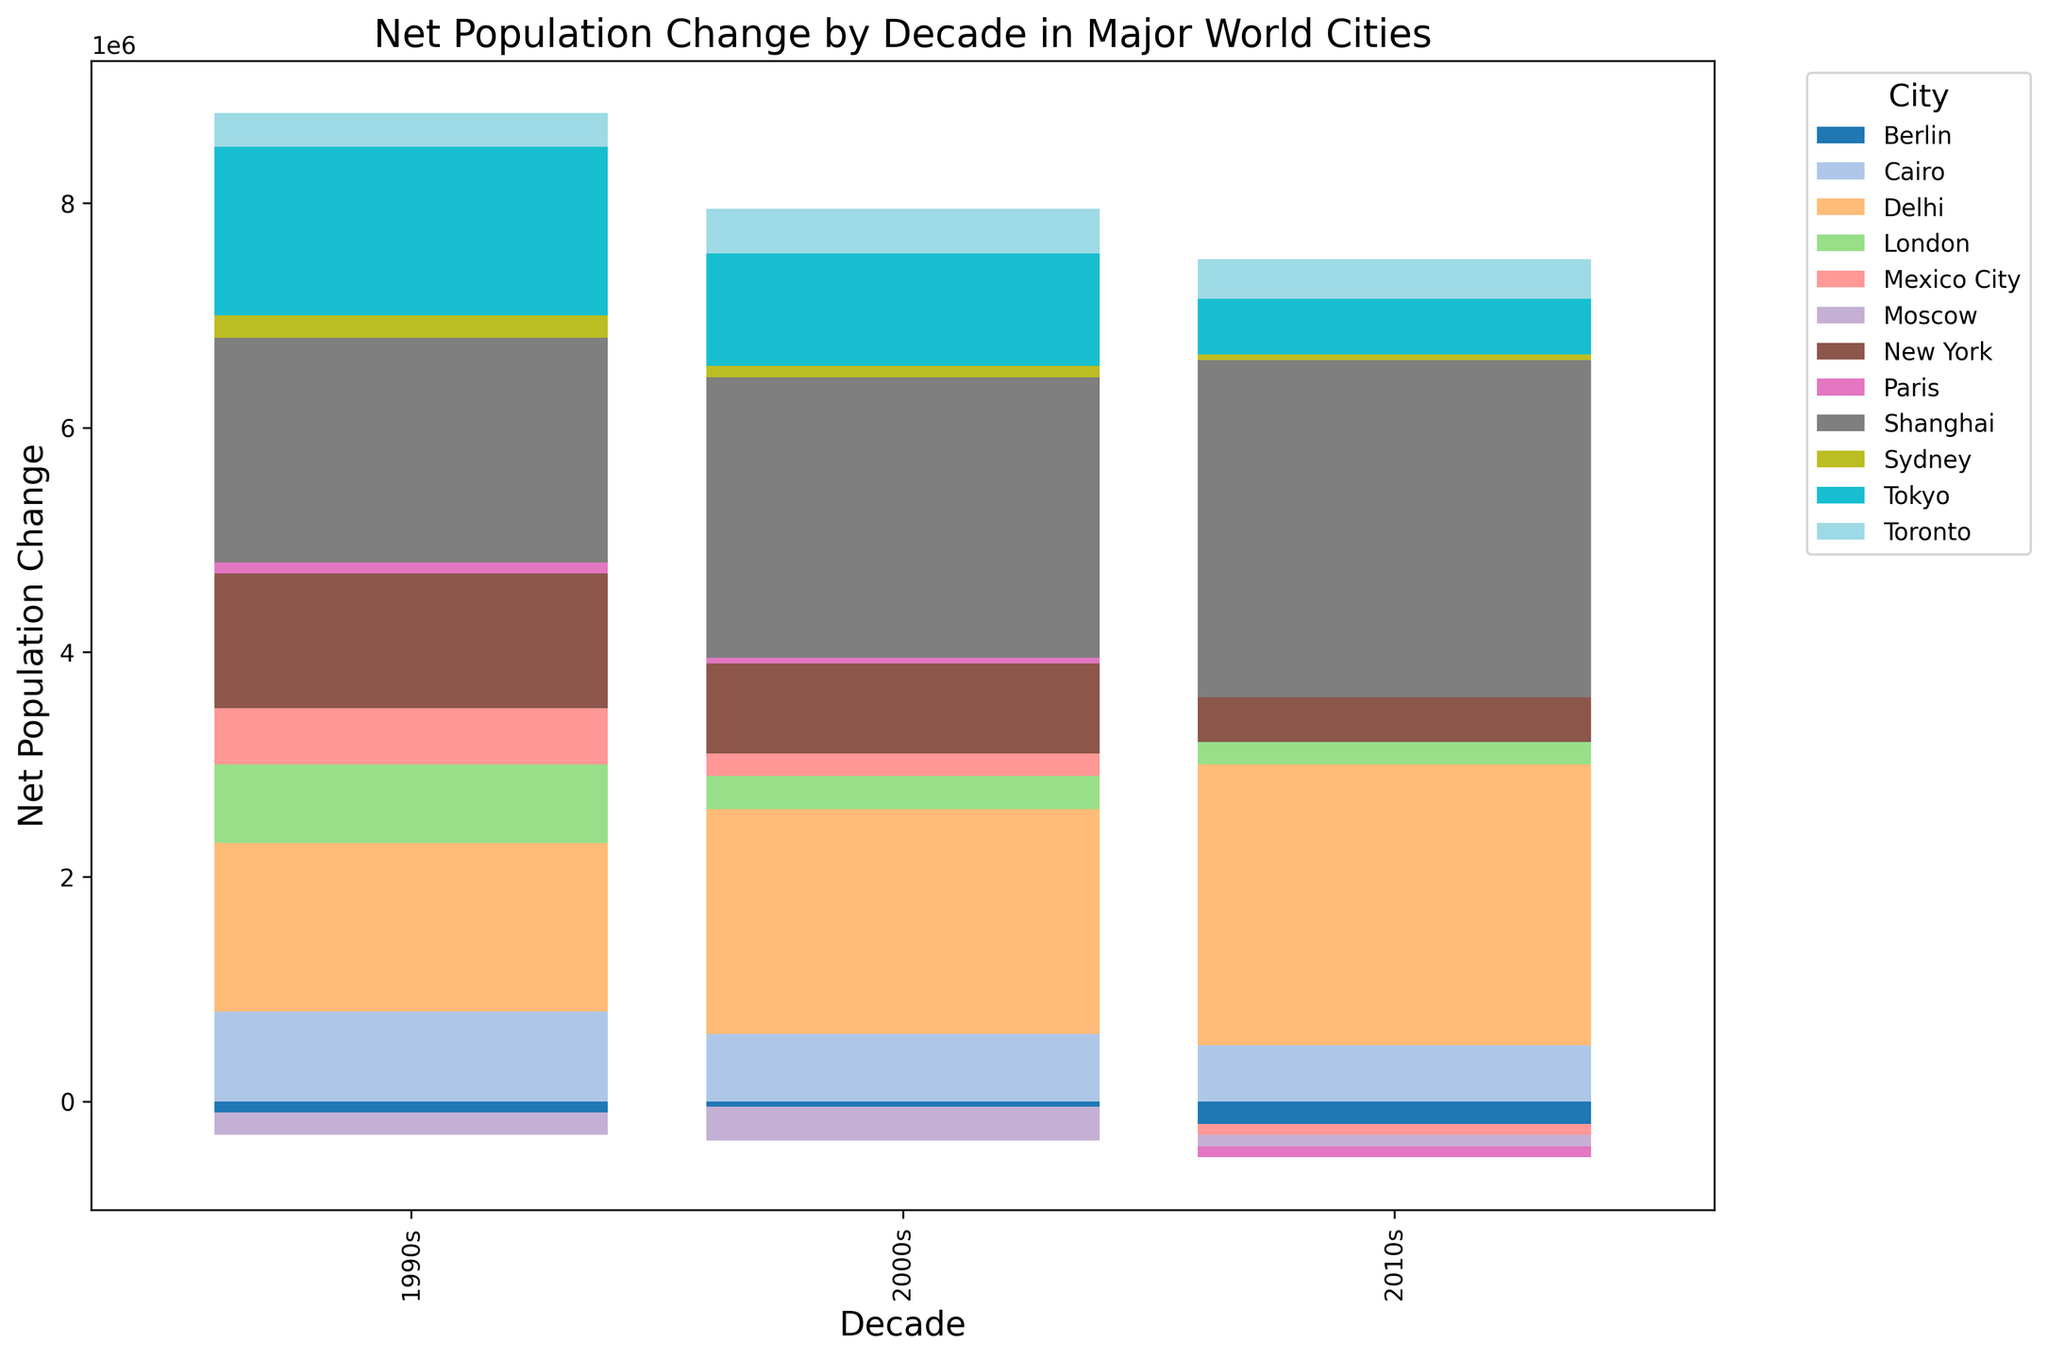What is the net population change for New York in the 2000s? Looking at the bar that represents New York in the 2000s decade, the height of the bar reaches 800,000.
Answer: 800,000 Which city had the highest net population change in the 1990s? By examining all the bars for each city in the 1990s, Shanghai's bar is the highest, indicating a net population change of 2,000,000.
Answer: Shanghai How many cities experienced a negative net population change in the 2010s? Looking at the bars in the 2010s decade, Berlin, Moscow, Mexico City, and Paris have bars below the x-axis, indicating negative net population changes.
Answer: 4 What is the total net population change in the 2000s across all cities combined? Sum up the heights of all the bars for each city in the 2000s: 800,000 (New York) + 1,000,000 (Tokyo) + (-50,000) (Berlin) + (-300,000) (Moscow) + 300,000 (London) + 2,500,000 (Shanghai) + 200,000 (Mexico City) + 600,000 (Cairo) + 50,000 (Paris) + 100,000 (Sydney) + 400,000 (Toronto) + 2,000,000 (Delhi).
Answer: 7,600,000 Which city saw the largest reduction in net population change from the 1990s to the 2010s? Calculate the difference in net population change for each city between these two decades: New York (1,200,000 to 400,000, change = -800,000), Tokyo (1,500,000 to 500,000, change = -1,000,000), Berlin (-100,000 to -200,000, change = -100,000), Moscow (-200,000 to -100,000, change = 100,000), London (700,000 to 200,000, change = -500,000), Shanghai (2,000,000 to 3,000,000, change = 1,000,000), Mexico City (500,000 to -100,000, change = -600,000), Cairo (800,000 to 500,000, change = -300,000), Paris (100,000 to -100,000, change = -200,000), Sydney (200,000 to 50,000, change = -150,000), Toronto (300,000 to 350,000, change = 50,000), Delhi (1,500,000 to 2,500,000, change = 1,000,000). Tokyo experienced the largest reduction.
Answer: Tokyo What is the average net population change for New York across the three decades? Calculate the average: (1,200,000 + 800,000 + 400,000) / 3 = 2,400,000 / 3 = 800,000.
Answer: 800,000 Which city had the smallest net population change in the 2000s? Examining the 2000s bars, Paris' bar is the smallest with a net population change of 50,000.
Answer: Paris What was the net population change in Berlin over the three decades combined? Sum up Berlin’s net population changes: -100,000 (1990s) + (-50,000) (2000s) + (-200,000) (2010s).
Answer: -350,000 